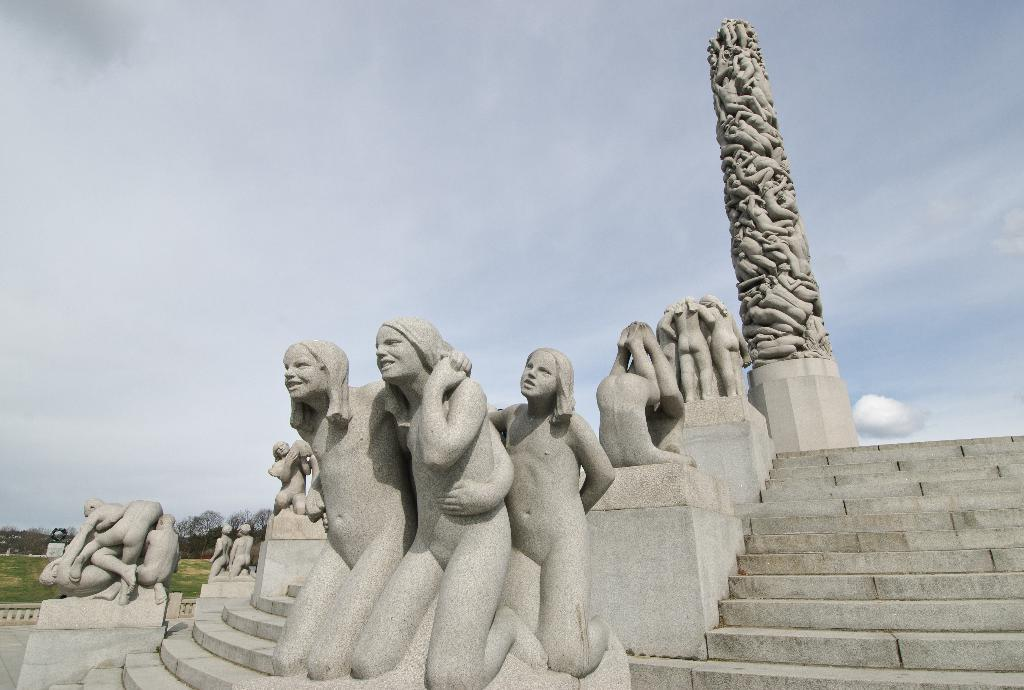What type of objects are depicted as statues in the image? The statues in the image are of human beings. What can be seen on the right side of the image? There is a pillar on the right side of the image. What is visible in the background of the image? There are clouds in the sky in the background of the image. What type of organization is being held in the image? There is no indication of an organization or event taking place in the image; it primarily features statues and a pillar. 